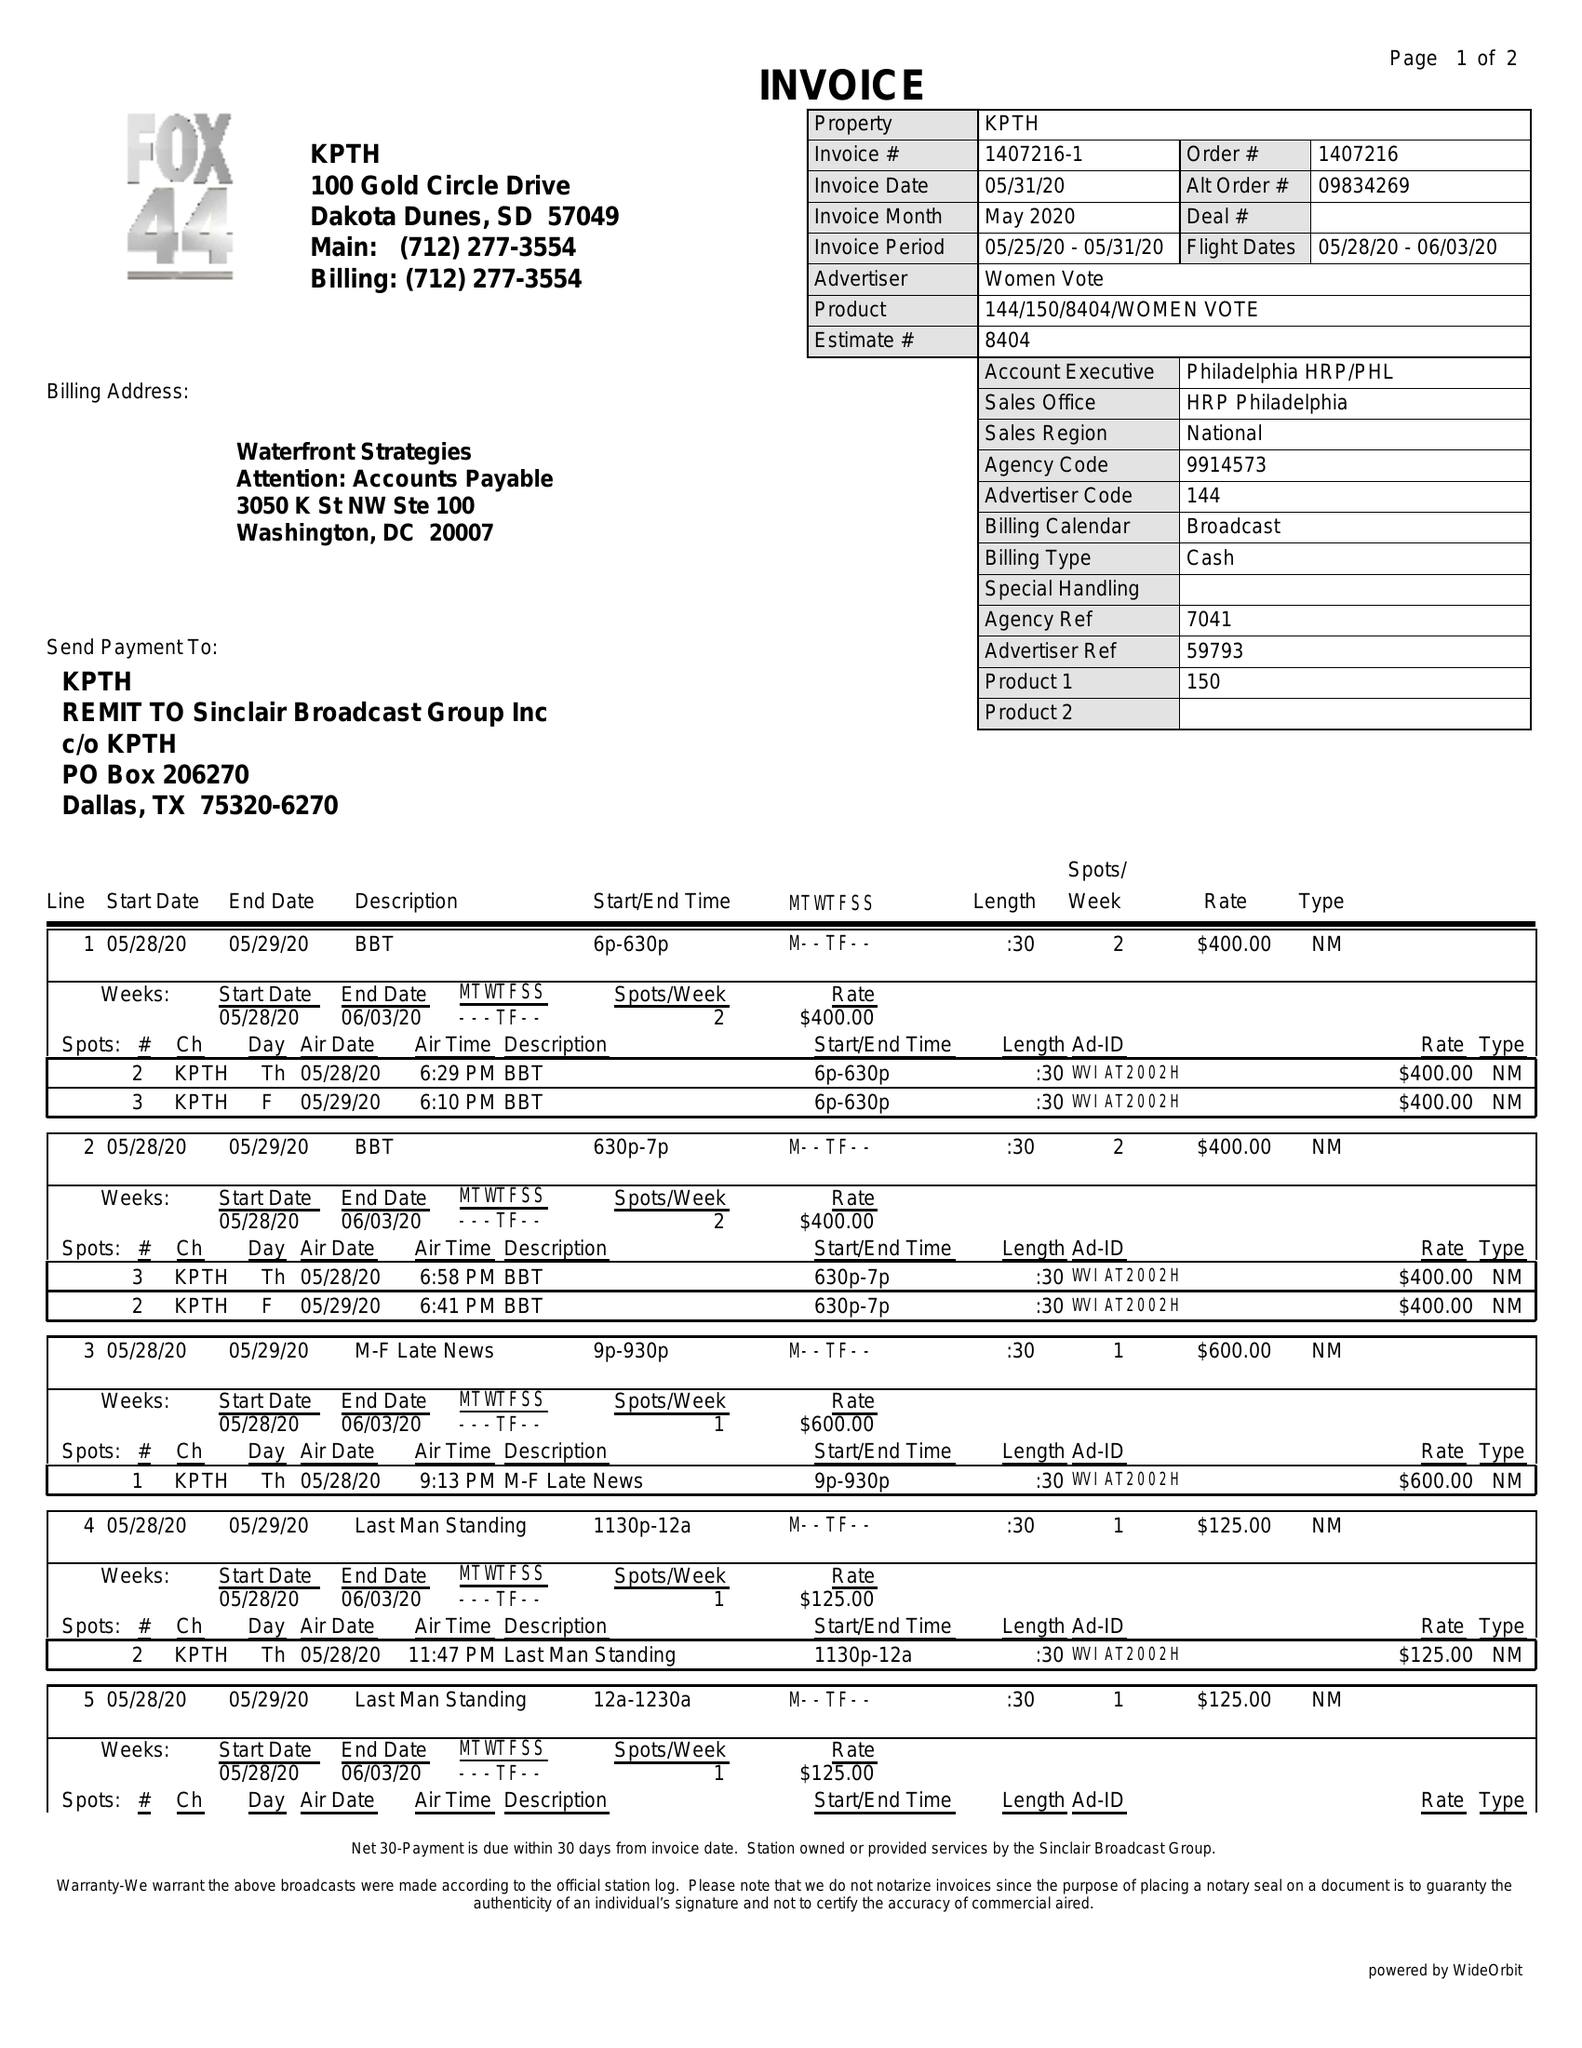What is the value for the flight_from?
Answer the question using a single word or phrase. 05/28/20 